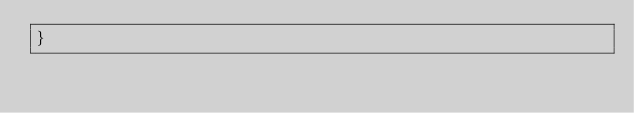<code> <loc_0><loc_0><loc_500><loc_500><_Rust_>}
</code> 